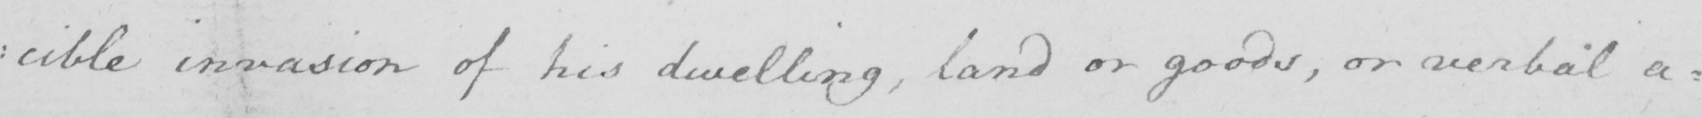What is written in this line of handwriting? : cible invasion of his dwelling , land or goods , or verbal a= 